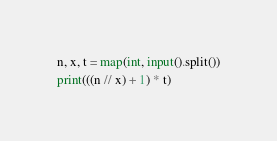<code> <loc_0><loc_0><loc_500><loc_500><_Python_>n, x, t = map(int, input().split())

print(((n // x) + 1) * t)</code> 